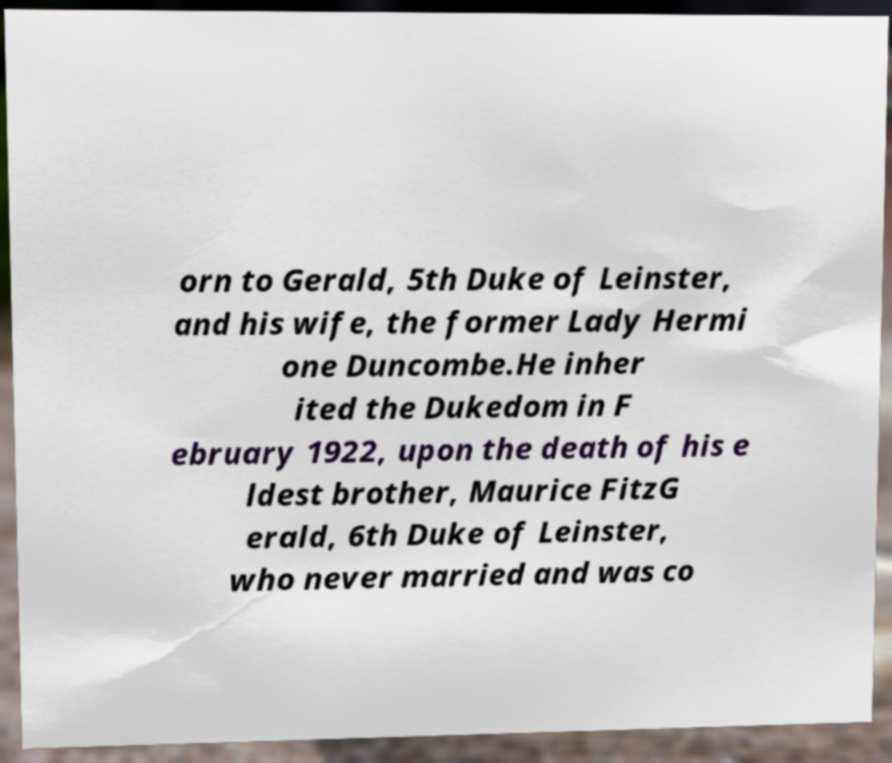What messages or text are displayed in this image? I need them in a readable, typed format. orn to Gerald, 5th Duke of Leinster, and his wife, the former Lady Hermi one Duncombe.He inher ited the Dukedom in F ebruary 1922, upon the death of his e ldest brother, Maurice FitzG erald, 6th Duke of Leinster, who never married and was co 